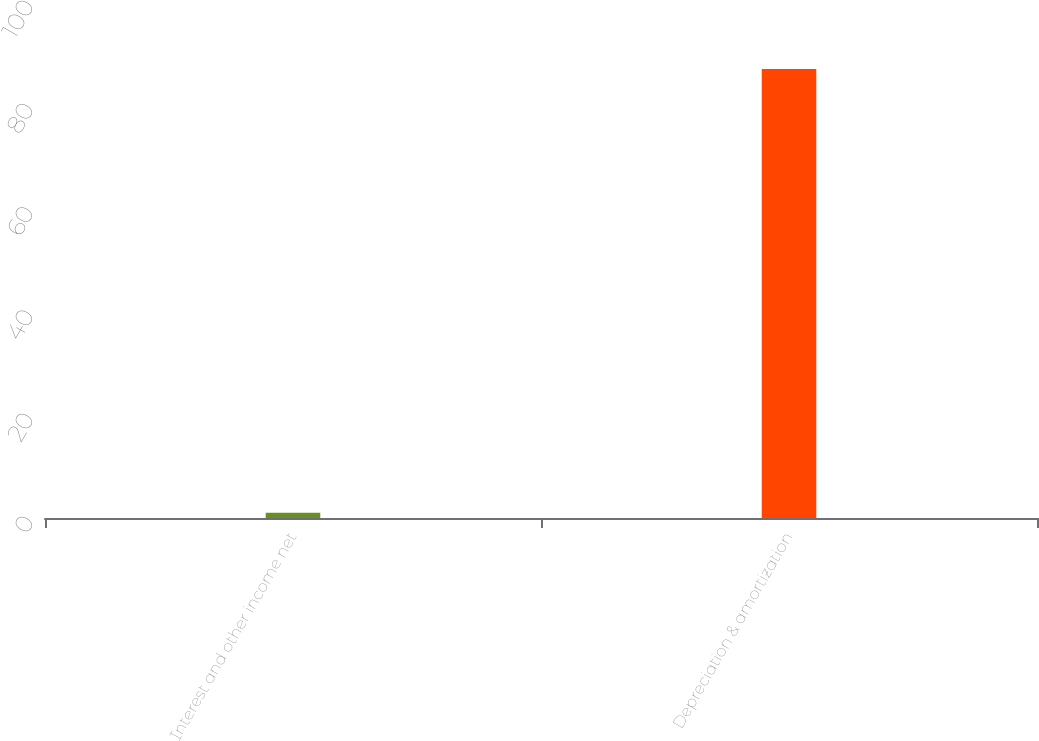Convert chart. <chart><loc_0><loc_0><loc_500><loc_500><bar_chart><fcel>Interest and other income net<fcel>Depreciation & amortization<nl><fcel>1<fcel>87<nl></chart> 